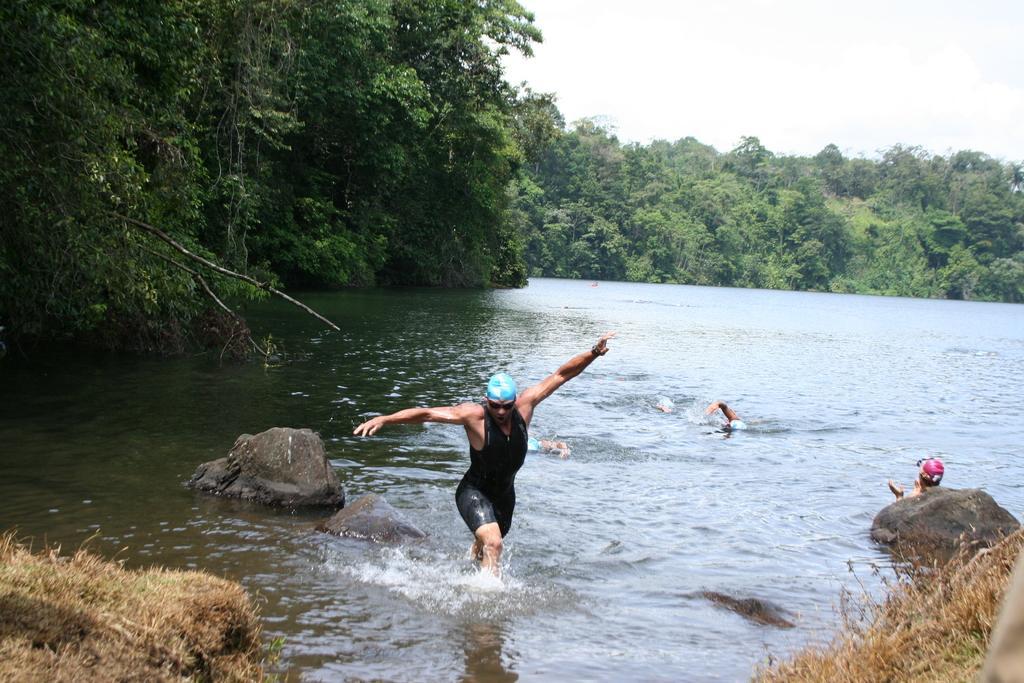Can you describe this image briefly? In this picture I can see the grass in front and in the middle of this picture I can see the water, in which I see few persons and I see the rocks. In the background I can see the trees and the sky. 